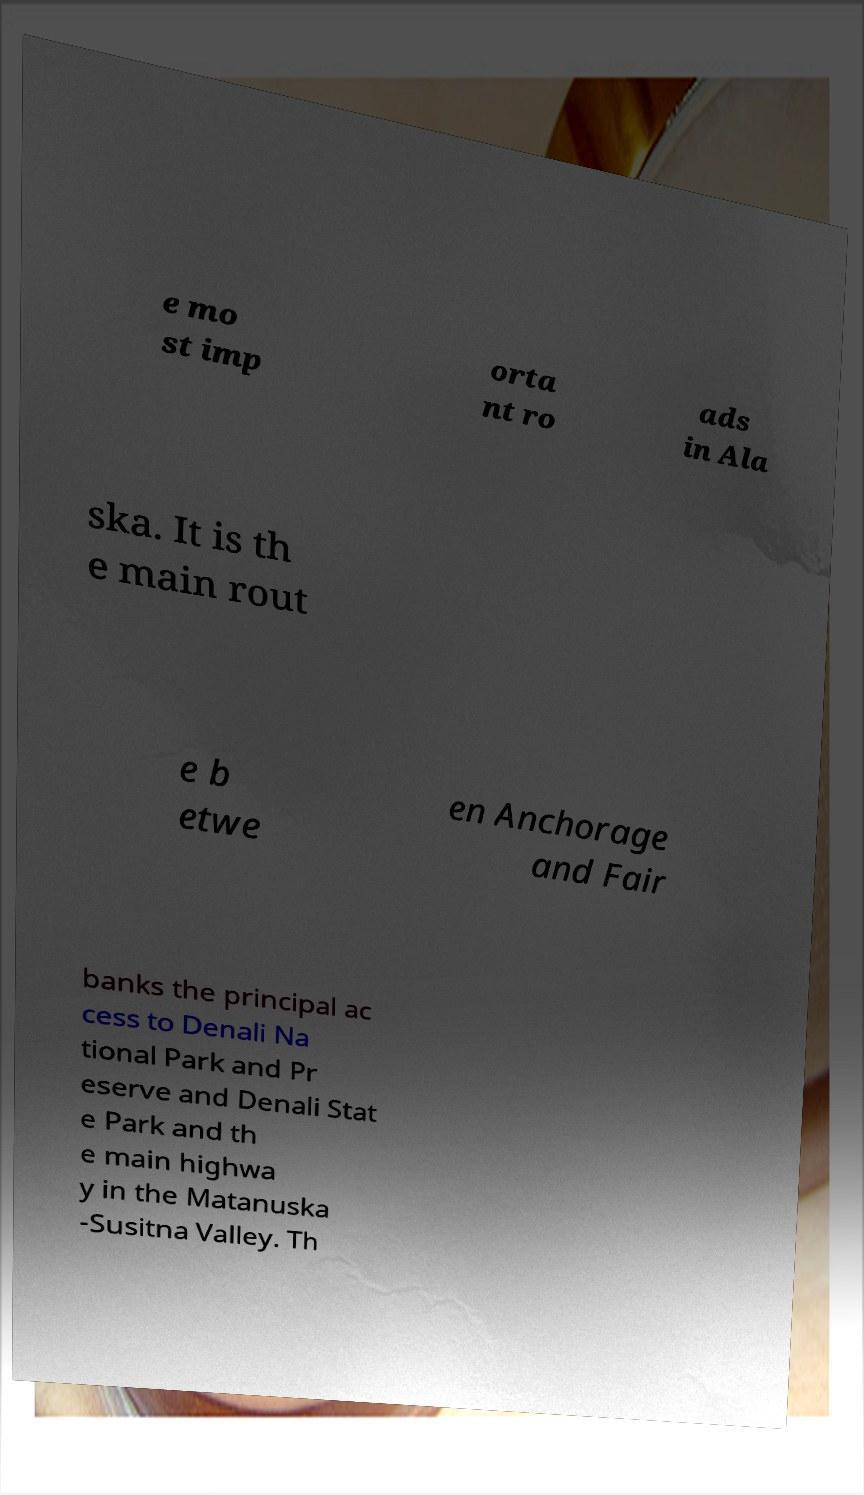There's text embedded in this image that I need extracted. Can you transcribe it verbatim? e mo st imp orta nt ro ads in Ala ska. It is th e main rout e b etwe en Anchorage and Fair banks the principal ac cess to Denali Na tional Park and Pr eserve and Denali Stat e Park and th e main highwa y in the Matanuska -Susitna Valley. Th 